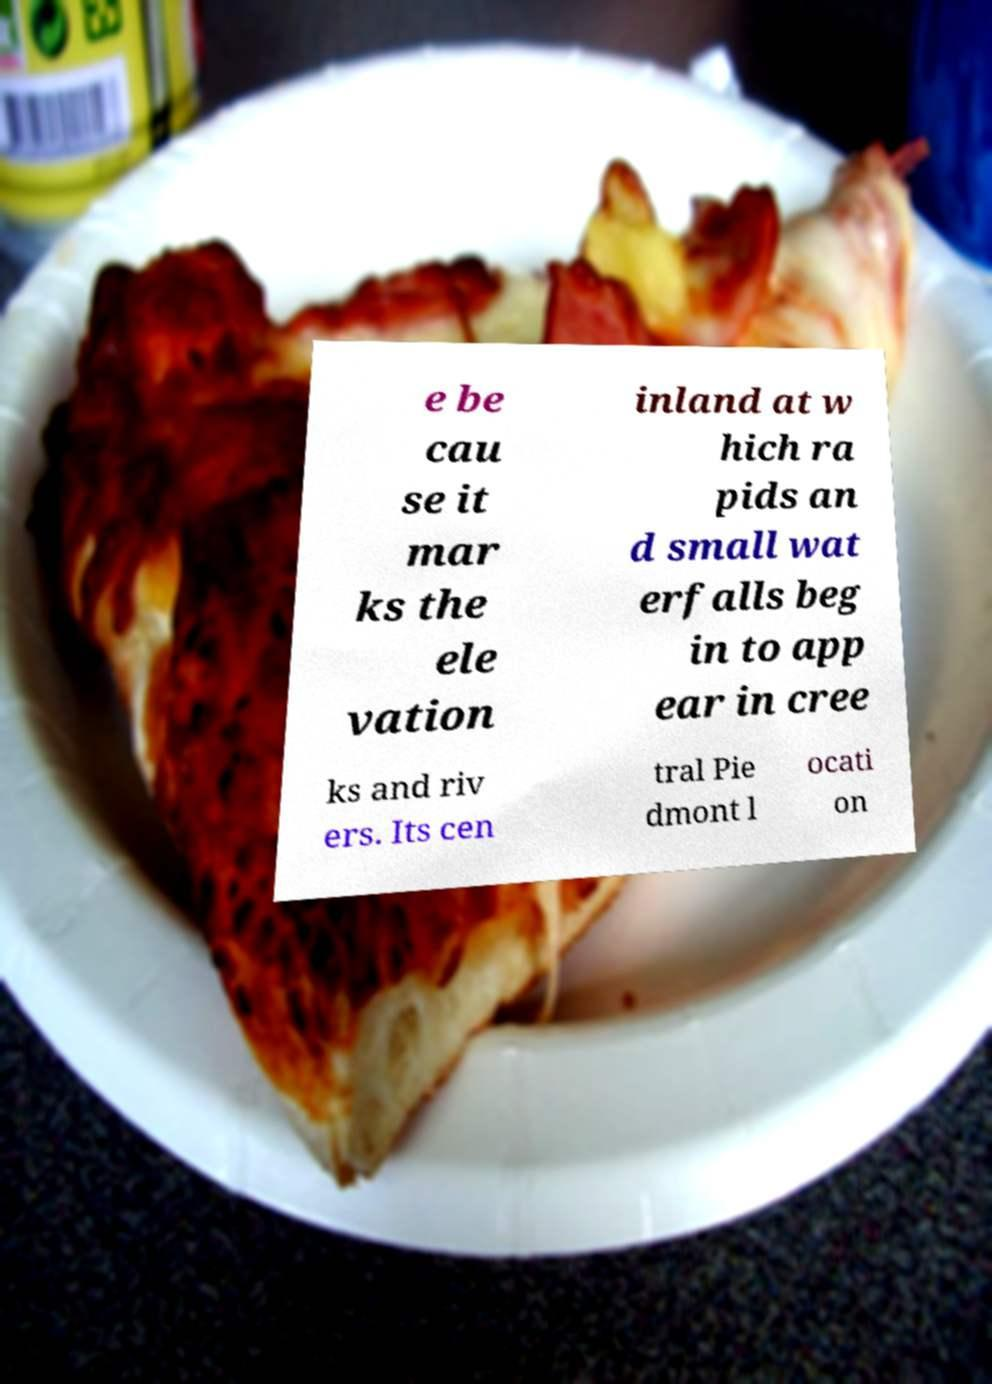I need the written content from this picture converted into text. Can you do that? e be cau se it mar ks the ele vation inland at w hich ra pids an d small wat erfalls beg in to app ear in cree ks and riv ers. Its cen tral Pie dmont l ocati on 